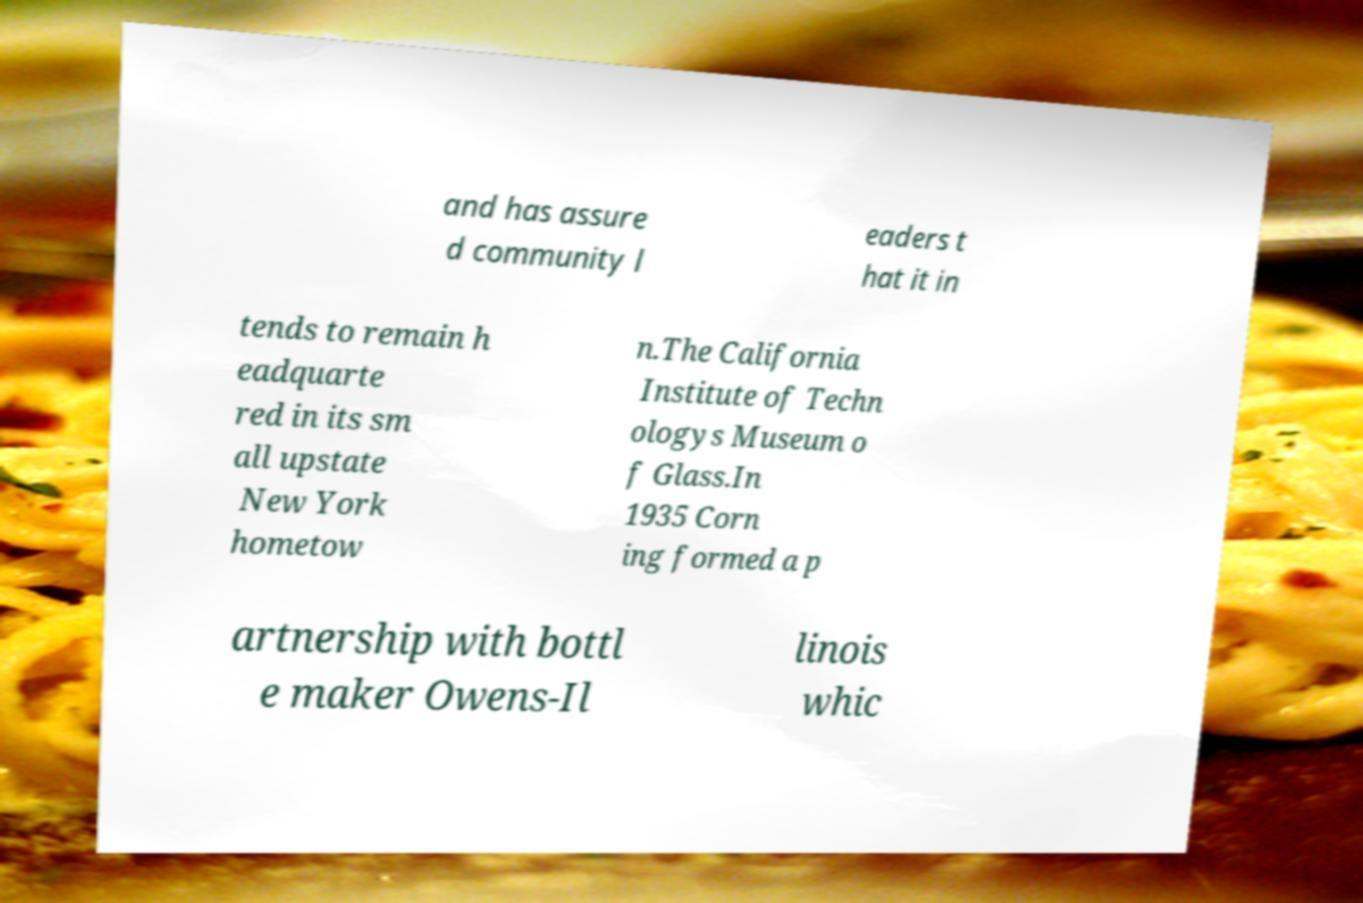For documentation purposes, I need the text within this image transcribed. Could you provide that? and has assure d community l eaders t hat it in tends to remain h eadquarte red in its sm all upstate New York hometow n.The California Institute of Techn ologys Museum o f Glass.In 1935 Corn ing formed a p artnership with bottl e maker Owens-Il linois whic 